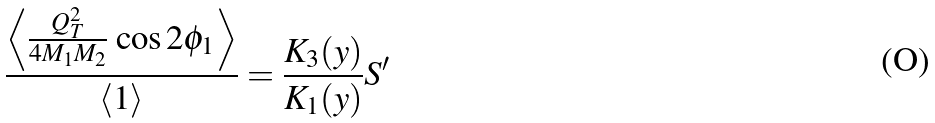<formula> <loc_0><loc_0><loc_500><loc_500>\frac { \left < \frac { Q _ { T } ^ { 2 } } { 4 M _ { 1 } M _ { 2 } } \, \cos 2 \phi _ { 1 } \right > } { \left < 1 \right > } = \frac { K _ { 3 } ( y ) } { K _ { 1 } ( y ) } S ^ { \prime }</formula> 